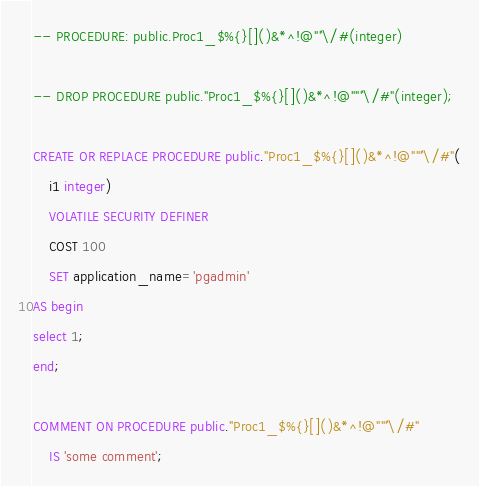Convert code to text. <code><loc_0><loc_0><loc_500><loc_500><_SQL_>-- PROCEDURE: public.Proc1_$%{}[]()&*^!@"'`\/#(integer)

-- DROP PROCEDURE public."Proc1_$%{}[]()&*^!@""'`\/#"(integer);

CREATE OR REPLACE PROCEDURE public."Proc1_$%{}[]()&*^!@""'`\/#"(
	i1 integer)
    VOLATILE SECURITY DEFINER
    COST 100
    SET application_name='pgadmin'
AS begin
select 1;
end;

COMMENT ON PROCEDURE public."Proc1_$%{}[]()&*^!@""'`\/#"
    IS 'some comment';
</code> 